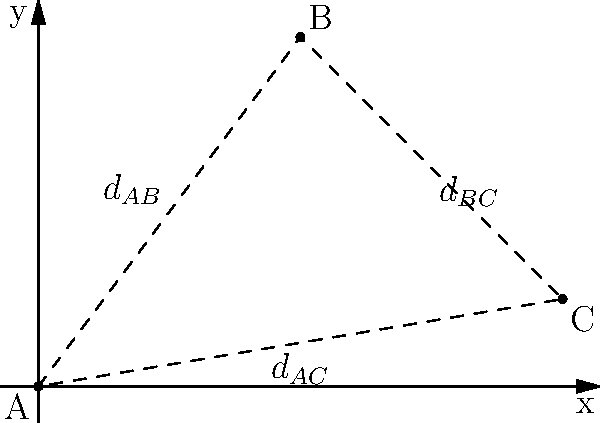In a mass grave excavation, three skeletal remains (A, B, and C) have been discovered at the following coordinates: A(0,0), B(3,4), and C(6,1). Using the distance formula, calculate the perimeter of the triangle formed by these three points. Round your answer to the nearest hundredth. To solve this problem, we need to follow these steps:

1. Recall the distance formula: 
   For two points $(x_1, y_1)$ and $(x_2, y_2)$, the distance is given by:
   $$d = \sqrt{(x_2-x_1)^2 + (y_2-y_1)^2}$$

2. Calculate the distance between A and B:
   $$d_{AB} = \sqrt{(3-0)^2 + (4-0)^2} = \sqrt{9 + 16} = \sqrt{25} = 5$$

3. Calculate the distance between B and C:
   $$d_{BC} = \sqrt{(6-3)^2 + (1-4)^2} = \sqrt{9 + (-3)^2} = \sqrt{18} \approx 4.24$$

4. Calculate the distance between A and C:
   $$d_{AC} = \sqrt{(6-0)^2 + (1-0)^2} = \sqrt{36 + 1} = \sqrt{37} \approx 6.08$$

5. Sum up all the distances to get the perimeter:
   $$\text{Perimeter} = d_{AB} + d_{BC} + d_{AC} = 5 + 4.24 + 6.08 = 15.32$$

6. Round to the nearest hundredth:
   15.32 (already rounded)

Therefore, the perimeter of the triangle formed by the three skeletal remains is approximately 15.32 units.
Answer: 15.32 units 